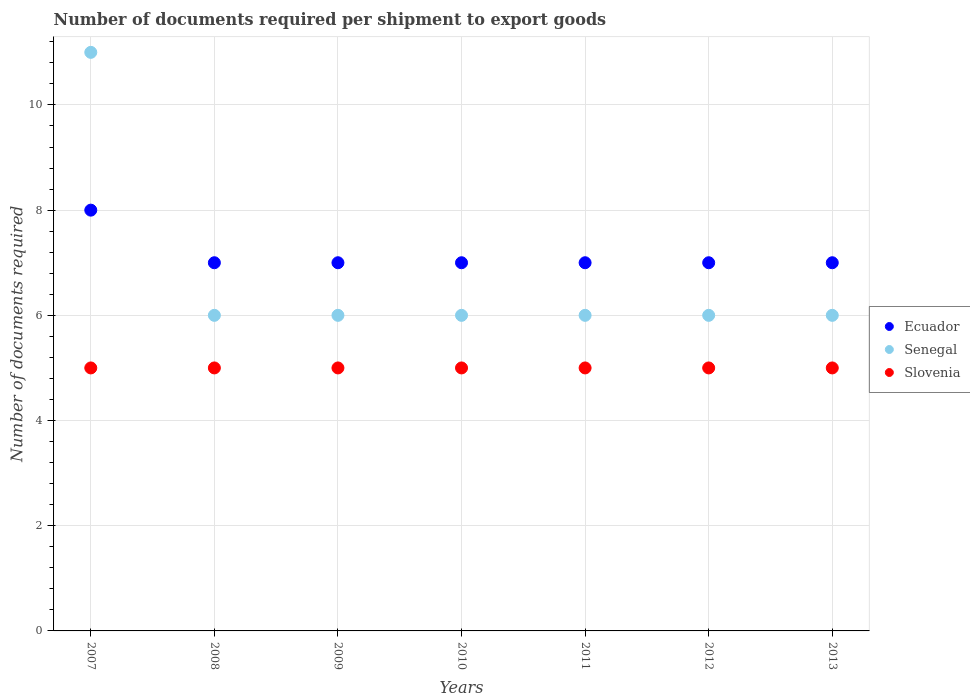How many different coloured dotlines are there?
Give a very brief answer. 3. Is the number of dotlines equal to the number of legend labels?
Offer a very short reply. Yes. What is the number of documents required per shipment to export goods in Ecuador in 2011?
Provide a short and direct response. 7. Across all years, what is the maximum number of documents required per shipment to export goods in Slovenia?
Provide a succinct answer. 5. Across all years, what is the minimum number of documents required per shipment to export goods in Ecuador?
Give a very brief answer. 7. In which year was the number of documents required per shipment to export goods in Ecuador maximum?
Offer a terse response. 2007. In which year was the number of documents required per shipment to export goods in Ecuador minimum?
Offer a very short reply. 2008. What is the total number of documents required per shipment to export goods in Slovenia in the graph?
Give a very brief answer. 35. What is the difference between the number of documents required per shipment to export goods in Senegal in 2009 and that in 2013?
Keep it short and to the point. 0. What is the average number of documents required per shipment to export goods in Senegal per year?
Keep it short and to the point. 6.71. In the year 2010, what is the difference between the number of documents required per shipment to export goods in Senegal and number of documents required per shipment to export goods in Ecuador?
Your answer should be very brief. -1. In how many years, is the number of documents required per shipment to export goods in Senegal greater than 3.2?
Provide a short and direct response. 7. Is the number of documents required per shipment to export goods in Slovenia in 2007 less than that in 2009?
Offer a terse response. No. Is the difference between the number of documents required per shipment to export goods in Senegal in 2007 and 2012 greater than the difference between the number of documents required per shipment to export goods in Ecuador in 2007 and 2012?
Make the answer very short. Yes. What is the difference between the highest and the lowest number of documents required per shipment to export goods in Slovenia?
Make the answer very short. 0. In how many years, is the number of documents required per shipment to export goods in Ecuador greater than the average number of documents required per shipment to export goods in Ecuador taken over all years?
Your answer should be compact. 1. Is it the case that in every year, the sum of the number of documents required per shipment to export goods in Ecuador and number of documents required per shipment to export goods in Senegal  is greater than the number of documents required per shipment to export goods in Slovenia?
Keep it short and to the point. Yes. How many dotlines are there?
Provide a succinct answer. 3. What is the difference between two consecutive major ticks on the Y-axis?
Your answer should be compact. 2. Does the graph contain any zero values?
Provide a short and direct response. No. How are the legend labels stacked?
Offer a very short reply. Vertical. What is the title of the graph?
Make the answer very short. Number of documents required per shipment to export goods. Does "Argentina" appear as one of the legend labels in the graph?
Ensure brevity in your answer.  No. What is the label or title of the X-axis?
Give a very brief answer. Years. What is the label or title of the Y-axis?
Provide a succinct answer. Number of documents required. What is the Number of documents required of Ecuador in 2007?
Make the answer very short. 8. What is the Number of documents required of Slovenia in 2007?
Give a very brief answer. 5. What is the Number of documents required of Senegal in 2008?
Your answer should be compact. 6. What is the Number of documents required of Slovenia in 2008?
Your response must be concise. 5. What is the Number of documents required in Ecuador in 2010?
Give a very brief answer. 7. What is the Number of documents required in Senegal in 2010?
Offer a very short reply. 6. What is the Number of documents required in Ecuador in 2011?
Your response must be concise. 7. What is the Number of documents required in Senegal in 2011?
Provide a short and direct response. 6. What is the Number of documents required of Slovenia in 2011?
Your response must be concise. 5. What is the Number of documents required in Ecuador in 2012?
Offer a very short reply. 7. What is the Number of documents required in Senegal in 2012?
Your answer should be compact. 6. What is the Number of documents required of Senegal in 2013?
Ensure brevity in your answer.  6. Across all years, what is the maximum Number of documents required in Senegal?
Provide a succinct answer. 11. Across all years, what is the maximum Number of documents required of Slovenia?
Your answer should be very brief. 5. What is the total Number of documents required of Senegal in the graph?
Offer a terse response. 47. What is the total Number of documents required of Slovenia in the graph?
Your response must be concise. 35. What is the difference between the Number of documents required of Senegal in 2007 and that in 2008?
Your response must be concise. 5. What is the difference between the Number of documents required in Slovenia in 2007 and that in 2008?
Provide a short and direct response. 0. What is the difference between the Number of documents required in Slovenia in 2007 and that in 2009?
Provide a short and direct response. 0. What is the difference between the Number of documents required of Senegal in 2007 and that in 2010?
Offer a very short reply. 5. What is the difference between the Number of documents required of Slovenia in 2007 and that in 2010?
Make the answer very short. 0. What is the difference between the Number of documents required in Ecuador in 2007 and that in 2011?
Your response must be concise. 1. What is the difference between the Number of documents required of Senegal in 2007 and that in 2012?
Give a very brief answer. 5. What is the difference between the Number of documents required of Senegal in 2007 and that in 2013?
Provide a short and direct response. 5. What is the difference between the Number of documents required in Slovenia in 2007 and that in 2013?
Make the answer very short. 0. What is the difference between the Number of documents required in Senegal in 2008 and that in 2009?
Offer a terse response. 0. What is the difference between the Number of documents required in Senegal in 2008 and that in 2010?
Your answer should be very brief. 0. What is the difference between the Number of documents required in Ecuador in 2008 and that in 2011?
Provide a short and direct response. 0. What is the difference between the Number of documents required in Senegal in 2008 and that in 2011?
Your answer should be very brief. 0. What is the difference between the Number of documents required of Slovenia in 2008 and that in 2011?
Offer a terse response. 0. What is the difference between the Number of documents required in Slovenia in 2008 and that in 2012?
Provide a succinct answer. 0. What is the difference between the Number of documents required in Senegal in 2008 and that in 2013?
Ensure brevity in your answer.  0. What is the difference between the Number of documents required in Slovenia in 2008 and that in 2013?
Your response must be concise. 0. What is the difference between the Number of documents required of Senegal in 2009 and that in 2011?
Keep it short and to the point. 0. What is the difference between the Number of documents required in Slovenia in 2009 and that in 2011?
Make the answer very short. 0. What is the difference between the Number of documents required of Ecuador in 2009 and that in 2012?
Make the answer very short. 0. What is the difference between the Number of documents required of Ecuador in 2009 and that in 2013?
Your answer should be compact. 0. What is the difference between the Number of documents required of Slovenia in 2009 and that in 2013?
Offer a very short reply. 0. What is the difference between the Number of documents required of Ecuador in 2010 and that in 2011?
Your response must be concise. 0. What is the difference between the Number of documents required of Senegal in 2010 and that in 2011?
Provide a succinct answer. 0. What is the difference between the Number of documents required in Slovenia in 2010 and that in 2012?
Make the answer very short. 0. What is the difference between the Number of documents required in Slovenia in 2010 and that in 2013?
Ensure brevity in your answer.  0. What is the difference between the Number of documents required of Ecuador in 2011 and that in 2012?
Ensure brevity in your answer.  0. What is the difference between the Number of documents required in Senegal in 2011 and that in 2012?
Make the answer very short. 0. What is the difference between the Number of documents required in Slovenia in 2011 and that in 2012?
Ensure brevity in your answer.  0. What is the difference between the Number of documents required in Senegal in 2011 and that in 2013?
Provide a succinct answer. 0. What is the difference between the Number of documents required in Ecuador in 2012 and that in 2013?
Keep it short and to the point. 0. What is the difference between the Number of documents required of Senegal in 2012 and that in 2013?
Offer a very short reply. 0. What is the difference between the Number of documents required in Slovenia in 2012 and that in 2013?
Give a very brief answer. 0. What is the difference between the Number of documents required of Ecuador in 2007 and the Number of documents required of Senegal in 2008?
Your answer should be compact. 2. What is the difference between the Number of documents required in Ecuador in 2007 and the Number of documents required in Slovenia in 2009?
Your answer should be very brief. 3. What is the difference between the Number of documents required of Senegal in 2007 and the Number of documents required of Slovenia in 2009?
Offer a terse response. 6. What is the difference between the Number of documents required of Senegal in 2007 and the Number of documents required of Slovenia in 2010?
Provide a succinct answer. 6. What is the difference between the Number of documents required of Ecuador in 2007 and the Number of documents required of Slovenia in 2011?
Give a very brief answer. 3. What is the difference between the Number of documents required in Senegal in 2007 and the Number of documents required in Slovenia in 2011?
Your response must be concise. 6. What is the difference between the Number of documents required in Ecuador in 2007 and the Number of documents required in Slovenia in 2012?
Give a very brief answer. 3. What is the difference between the Number of documents required of Ecuador in 2007 and the Number of documents required of Senegal in 2013?
Provide a short and direct response. 2. What is the difference between the Number of documents required of Ecuador in 2007 and the Number of documents required of Slovenia in 2013?
Provide a short and direct response. 3. What is the difference between the Number of documents required in Ecuador in 2008 and the Number of documents required in Senegal in 2009?
Keep it short and to the point. 1. What is the difference between the Number of documents required of Ecuador in 2008 and the Number of documents required of Slovenia in 2009?
Your answer should be very brief. 2. What is the difference between the Number of documents required in Ecuador in 2008 and the Number of documents required in Senegal in 2010?
Keep it short and to the point. 1. What is the difference between the Number of documents required of Ecuador in 2008 and the Number of documents required of Slovenia in 2010?
Make the answer very short. 2. What is the difference between the Number of documents required of Ecuador in 2008 and the Number of documents required of Slovenia in 2011?
Your answer should be very brief. 2. What is the difference between the Number of documents required in Ecuador in 2008 and the Number of documents required in Senegal in 2013?
Give a very brief answer. 1. What is the difference between the Number of documents required of Ecuador in 2008 and the Number of documents required of Slovenia in 2013?
Provide a succinct answer. 2. What is the difference between the Number of documents required of Senegal in 2008 and the Number of documents required of Slovenia in 2013?
Offer a terse response. 1. What is the difference between the Number of documents required in Ecuador in 2009 and the Number of documents required in Senegal in 2010?
Offer a very short reply. 1. What is the difference between the Number of documents required in Ecuador in 2009 and the Number of documents required in Slovenia in 2010?
Give a very brief answer. 2. What is the difference between the Number of documents required of Ecuador in 2009 and the Number of documents required of Senegal in 2012?
Your answer should be compact. 1. What is the difference between the Number of documents required of Ecuador in 2009 and the Number of documents required of Senegal in 2013?
Provide a succinct answer. 1. What is the difference between the Number of documents required of Senegal in 2010 and the Number of documents required of Slovenia in 2011?
Provide a short and direct response. 1. What is the difference between the Number of documents required of Ecuador in 2010 and the Number of documents required of Senegal in 2012?
Ensure brevity in your answer.  1. What is the difference between the Number of documents required of Senegal in 2010 and the Number of documents required of Slovenia in 2013?
Keep it short and to the point. 1. What is the difference between the Number of documents required in Ecuador in 2011 and the Number of documents required in Slovenia in 2012?
Ensure brevity in your answer.  2. What is the difference between the Number of documents required in Senegal in 2011 and the Number of documents required in Slovenia in 2012?
Provide a succinct answer. 1. What is the difference between the Number of documents required of Senegal in 2011 and the Number of documents required of Slovenia in 2013?
Offer a very short reply. 1. What is the difference between the Number of documents required of Ecuador in 2012 and the Number of documents required of Slovenia in 2013?
Offer a terse response. 2. What is the difference between the Number of documents required of Senegal in 2012 and the Number of documents required of Slovenia in 2013?
Provide a short and direct response. 1. What is the average Number of documents required of Ecuador per year?
Keep it short and to the point. 7.14. What is the average Number of documents required of Senegal per year?
Your answer should be very brief. 6.71. What is the average Number of documents required of Slovenia per year?
Make the answer very short. 5. In the year 2007, what is the difference between the Number of documents required of Ecuador and Number of documents required of Senegal?
Offer a terse response. -3. In the year 2008, what is the difference between the Number of documents required in Ecuador and Number of documents required in Senegal?
Keep it short and to the point. 1. In the year 2008, what is the difference between the Number of documents required in Senegal and Number of documents required in Slovenia?
Keep it short and to the point. 1. In the year 2009, what is the difference between the Number of documents required in Senegal and Number of documents required in Slovenia?
Provide a succinct answer. 1. In the year 2010, what is the difference between the Number of documents required of Ecuador and Number of documents required of Slovenia?
Offer a terse response. 2. In the year 2011, what is the difference between the Number of documents required of Ecuador and Number of documents required of Senegal?
Keep it short and to the point. 1. In the year 2011, what is the difference between the Number of documents required in Ecuador and Number of documents required in Slovenia?
Offer a terse response. 2. In the year 2012, what is the difference between the Number of documents required in Ecuador and Number of documents required in Slovenia?
Provide a succinct answer. 2. What is the ratio of the Number of documents required of Ecuador in 2007 to that in 2008?
Provide a short and direct response. 1.14. What is the ratio of the Number of documents required of Senegal in 2007 to that in 2008?
Give a very brief answer. 1.83. What is the ratio of the Number of documents required of Slovenia in 2007 to that in 2008?
Give a very brief answer. 1. What is the ratio of the Number of documents required of Ecuador in 2007 to that in 2009?
Offer a very short reply. 1.14. What is the ratio of the Number of documents required of Senegal in 2007 to that in 2009?
Ensure brevity in your answer.  1.83. What is the ratio of the Number of documents required in Slovenia in 2007 to that in 2009?
Provide a succinct answer. 1. What is the ratio of the Number of documents required of Senegal in 2007 to that in 2010?
Keep it short and to the point. 1.83. What is the ratio of the Number of documents required of Slovenia in 2007 to that in 2010?
Give a very brief answer. 1. What is the ratio of the Number of documents required of Senegal in 2007 to that in 2011?
Provide a short and direct response. 1.83. What is the ratio of the Number of documents required of Senegal in 2007 to that in 2012?
Your response must be concise. 1.83. What is the ratio of the Number of documents required in Ecuador in 2007 to that in 2013?
Give a very brief answer. 1.14. What is the ratio of the Number of documents required in Senegal in 2007 to that in 2013?
Keep it short and to the point. 1.83. What is the ratio of the Number of documents required in Ecuador in 2008 to that in 2009?
Your answer should be compact. 1. What is the ratio of the Number of documents required in Senegal in 2008 to that in 2009?
Keep it short and to the point. 1. What is the ratio of the Number of documents required of Slovenia in 2008 to that in 2009?
Make the answer very short. 1. What is the ratio of the Number of documents required of Slovenia in 2008 to that in 2010?
Offer a very short reply. 1. What is the ratio of the Number of documents required in Senegal in 2008 to that in 2011?
Ensure brevity in your answer.  1. What is the ratio of the Number of documents required in Senegal in 2008 to that in 2012?
Ensure brevity in your answer.  1. What is the ratio of the Number of documents required of Slovenia in 2008 to that in 2012?
Your response must be concise. 1. What is the ratio of the Number of documents required in Ecuador in 2008 to that in 2013?
Give a very brief answer. 1. What is the ratio of the Number of documents required in Ecuador in 2009 to that in 2010?
Ensure brevity in your answer.  1. What is the ratio of the Number of documents required of Senegal in 2009 to that in 2011?
Keep it short and to the point. 1. What is the ratio of the Number of documents required in Slovenia in 2009 to that in 2011?
Ensure brevity in your answer.  1. What is the ratio of the Number of documents required of Slovenia in 2009 to that in 2012?
Your answer should be very brief. 1. What is the ratio of the Number of documents required of Senegal in 2009 to that in 2013?
Provide a succinct answer. 1. What is the ratio of the Number of documents required in Senegal in 2010 to that in 2011?
Keep it short and to the point. 1. What is the ratio of the Number of documents required of Slovenia in 2010 to that in 2012?
Keep it short and to the point. 1. What is the ratio of the Number of documents required of Ecuador in 2010 to that in 2013?
Keep it short and to the point. 1. What is the ratio of the Number of documents required of Ecuador in 2011 to that in 2013?
Offer a terse response. 1. What is the ratio of the Number of documents required of Senegal in 2011 to that in 2013?
Provide a short and direct response. 1. What is the difference between the highest and the second highest Number of documents required in Ecuador?
Provide a short and direct response. 1. What is the difference between the highest and the second highest Number of documents required of Senegal?
Keep it short and to the point. 5. What is the difference between the highest and the second highest Number of documents required in Slovenia?
Ensure brevity in your answer.  0. What is the difference between the highest and the lowest Number of documents required in Senegal?
Provide a short and direct response. 5. 